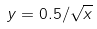<formula> <loc_0><loc_0><loc_500><loc_500>y = 0 . 5 / \sqrt { x }</formula> 